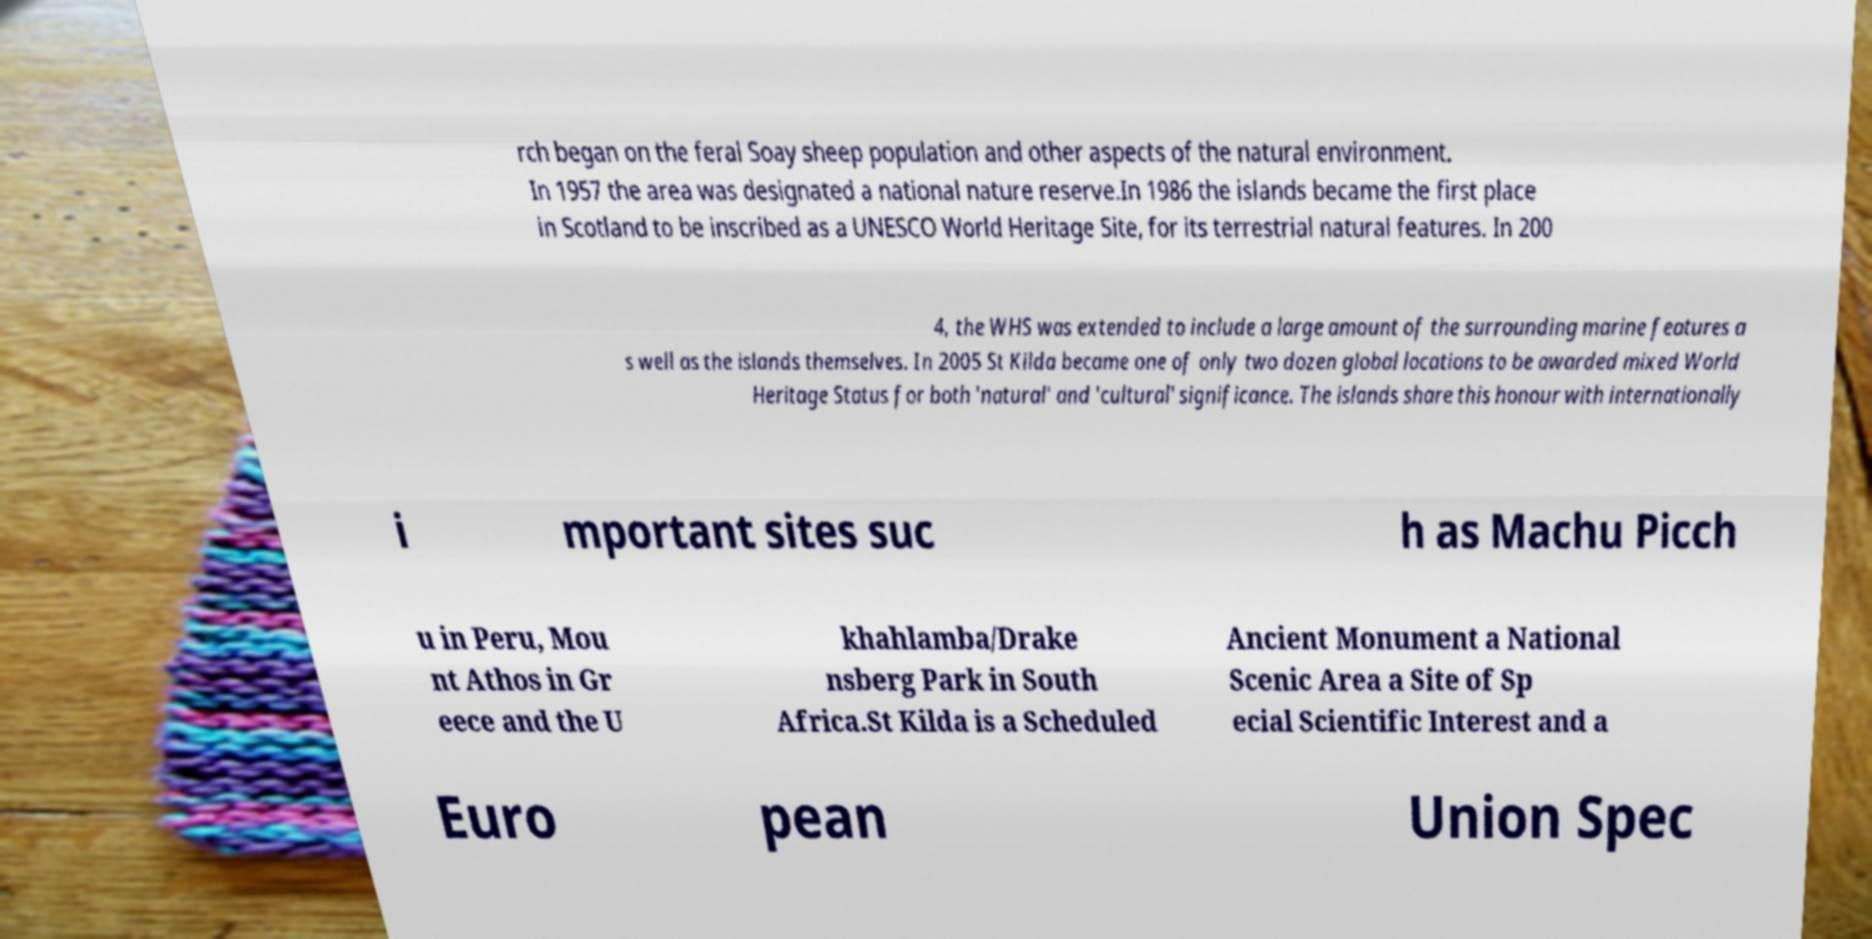I need the written content from this picture converted into text. Can you do that? rch began on the feral Soay sheep population and other aspects of the natural environment. In 1957 the area was designated a national nature reserve.In 1986 the islands became the first place in Scotland to be inscribed as a UNESCO World Heritage Site, for its terrestrial natural features. In 200 4, the WHS was extended to include a large amount of the surrounding marine features a s well as the islands themselves. In 2005 St Kilda became one of only two dozen global locations to be awarded mixed World Heritage Status for both 'natural' and 'cultural' significance. The islands share this honour with internationally i mportant sites suc h as Machu Picch u in Peru, Mou nt Athos in Gr eece and the U khahlamba/Drake nsberg Park in South Africa.St Kilda is a Scheduled Ancient Monument a National Scenic Area a Site of Sp ecial Scientific Interest and a Euro pean Union Spec 